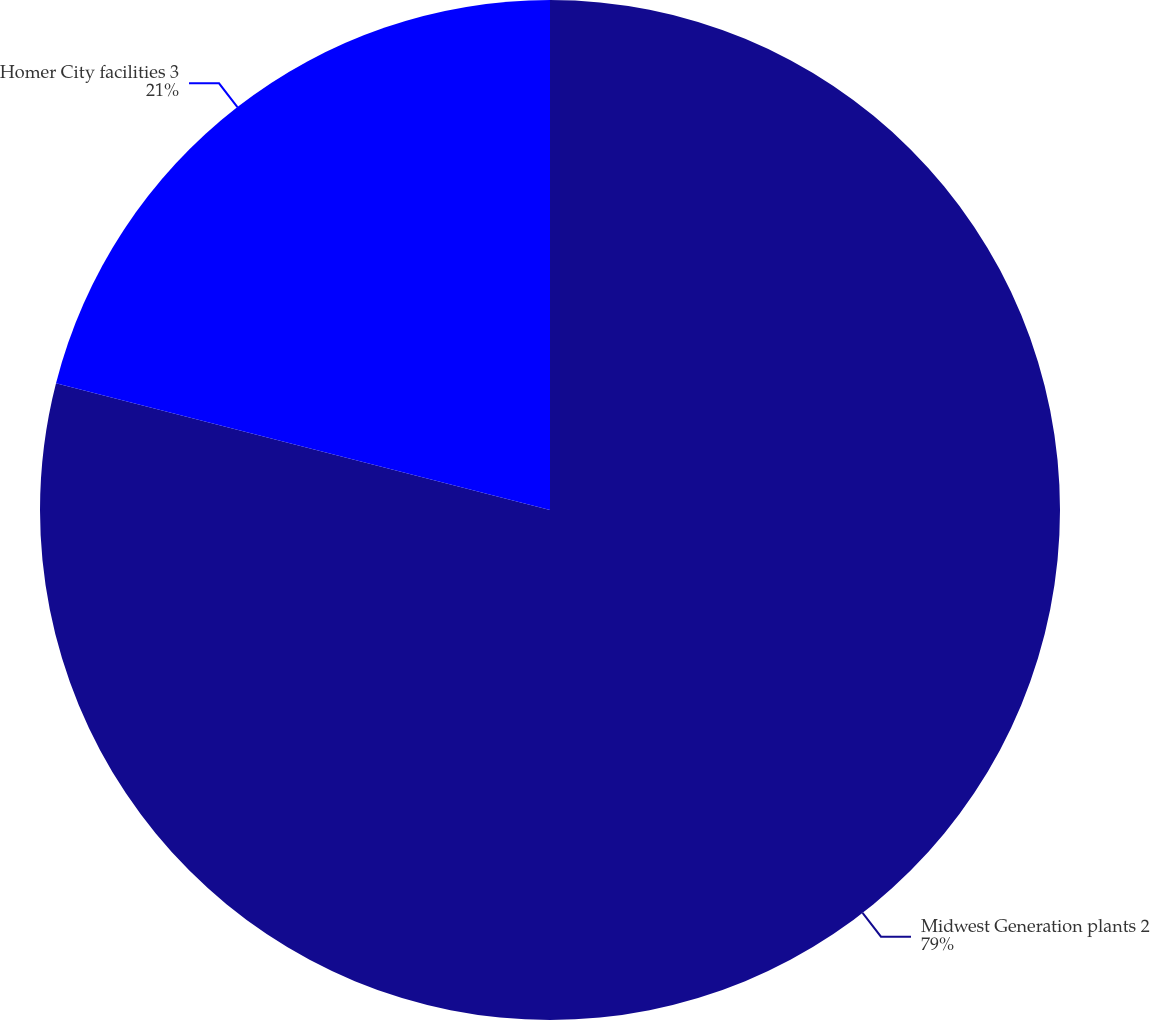Convert chart to OTSL. <chart><loc_0><loc_0><loc_500><loc_500><pie_chart><fcel>Midwest Generation plants 2<fcel>Homer City facilities 3<nl><fcel>79.0%<fcel>21.0%<nl></chart> 